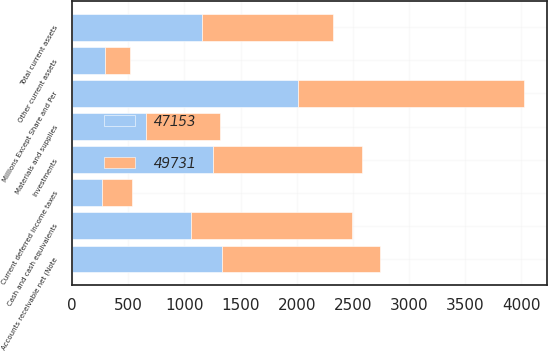<chart> <loc_0><loc_0><loc_500><loc_500><stacked_bar_chart><ecel><fcel>Millions Except Share and Per<fcel>Cash and cash equivalents<fcel>Accounts receivable net (Note<fcel>Materials and supplies<fcel>Current deferred income taxes<fcel>Other current assets<fcel>Total current assets<fcel>Investments<nl><fcel>49731<fcel>2013<fcel>1432<fcel>1414<fcel>653<fcel>268<fcel>223<fcel>1161<fcel>1321<nl><fcel>47153<fcel>2012<fcel>1063<fcel>1331<fcel>660<fcel>263<fcel>297<fcel>1161<fcel>1259<nl></chart> 